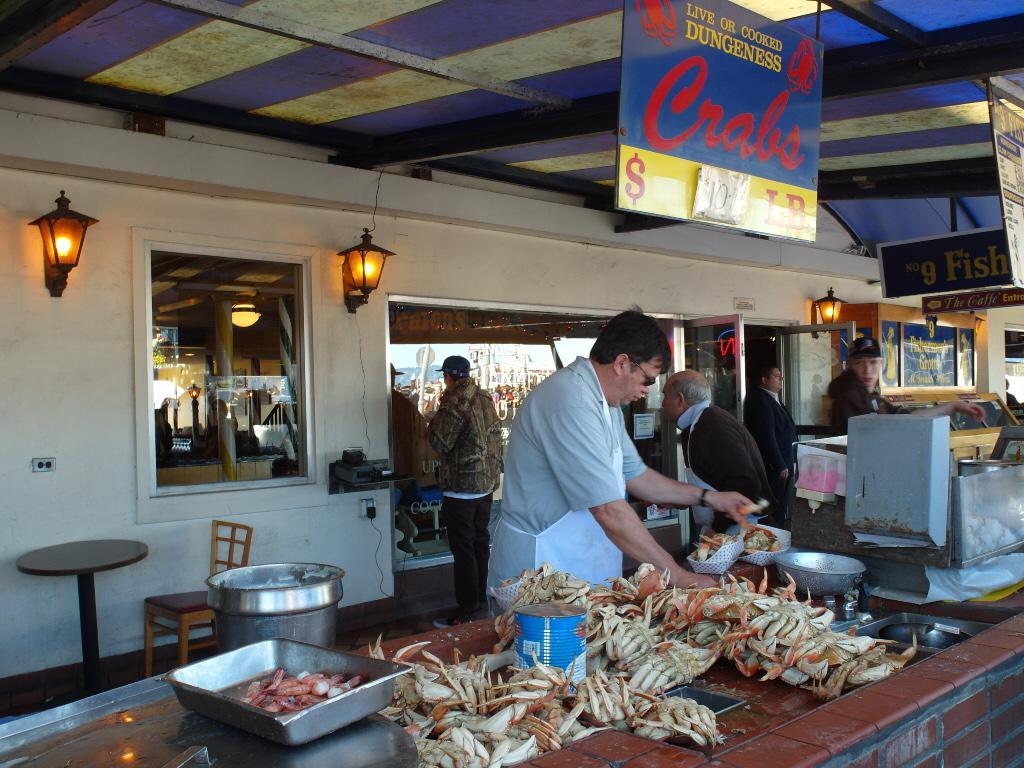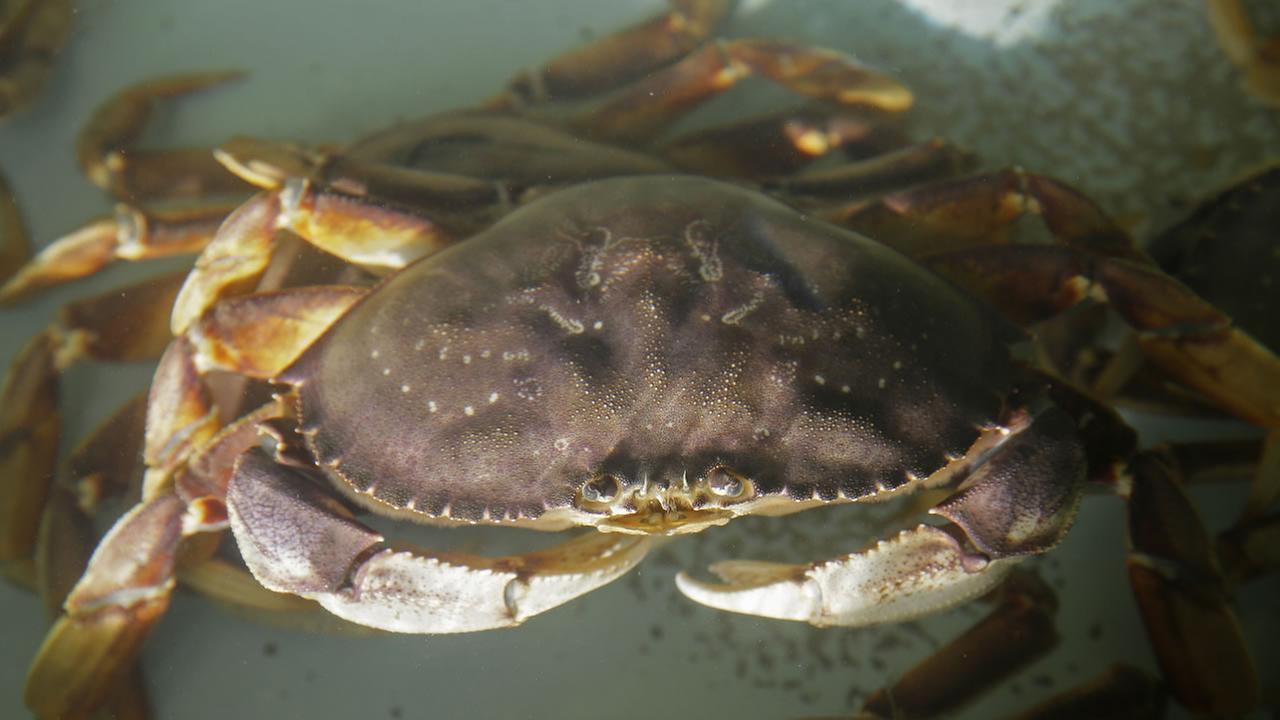The first image is the image on the left, the second image is the image on the right. Analyze the images presented: Is the assertion "In the left image, a man in an apron is behind a counter containing piles of upside-down crabs." valid? Answer yes or no. Yes. 